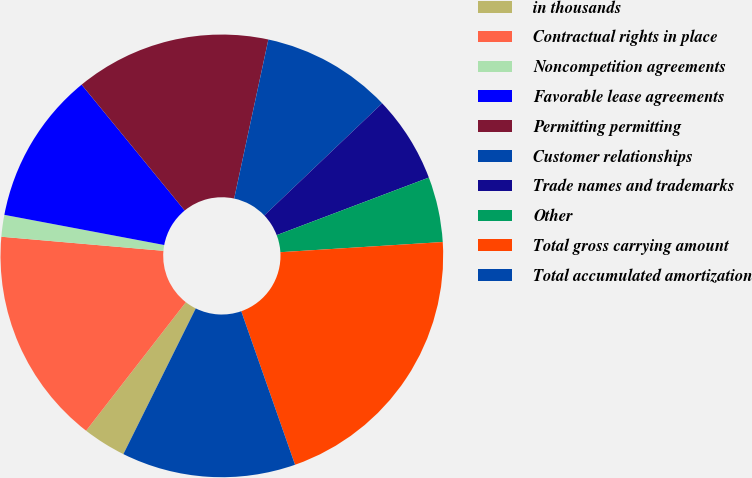Convert chart. <chart><loc_0><loc_0><loc_500><loc_500><pie_chart><fcel>in thousands<fcel>Contractual rights in place<fcel>Noncompetition agreements<fcel>Favorable lease agreements<fcel>Permitting permitting<fcel>Customer relationships<fcel>Trade names and trademarks<fcel>Other<fcel>Total gross carrying amount<fcel>Total accumulated amortization<nl><fcel>3.17%<fcel>15.87%<fcel>1.59%<fcel>11.11%<fcel>14.29%<fcel>9.52%<fcel>6.35%<fcel>4.76%<fcel>20.63%<fcel>12.7%<nl></chart> 